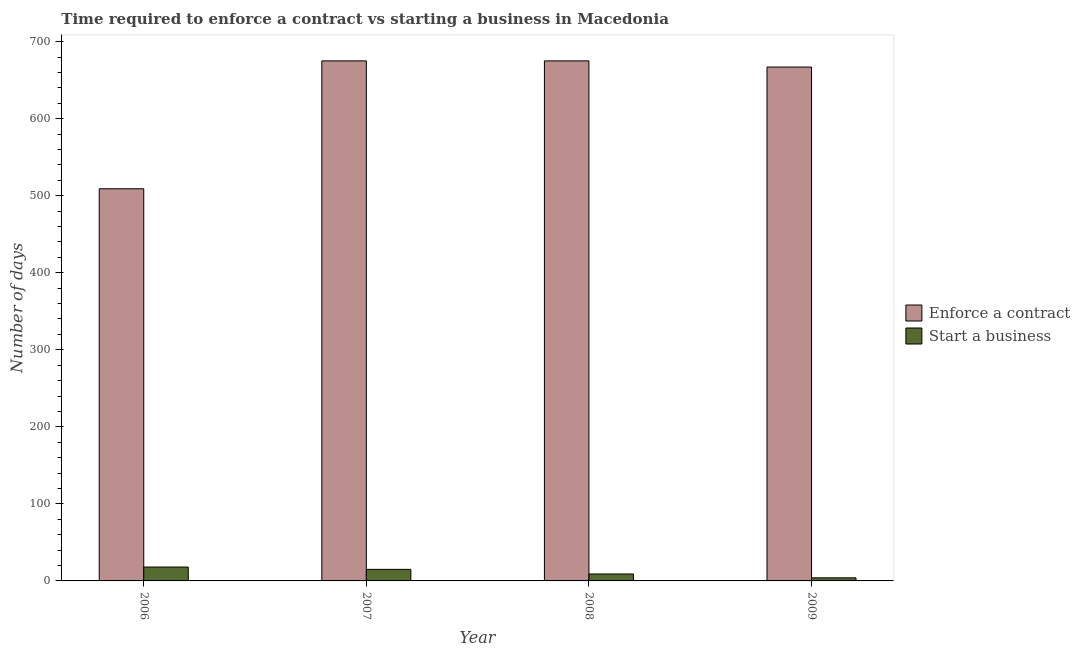How many different coloured bars are there?
Ensure brevity in your answer.  2. Are the number of bars on each tick of the X-axis equal?
Provide a short and direct response. Yes. What is the number of days to start a business in 2007?
Offer a terse response. 15. Across all years, what is the maximum number of days to enforece a contract?
Provide a succinct answer. 675. Across all years, what is the minimum number of days to enforece a contract?
Provide a short and direct response. 509. In which year was the number of days to enforece a contract maximum?
Your answer should be compact. 2007. In which year was the number of days to start a business minimum?
Keep it short and to the point. 2009. What is the total number of days to enforece a contract in the graph?
Give a very brief answer. 2526. What is the difference between the number of days to start a business in 2006 and that in 2008?
Provide a succinct answer. 9. What is the difference between the number of days to enforece a contract in 2009 and the number of days to start a business in 2006?
Ensure brevity in your answer.  158. What is the average number of days to enforece a contract per year?
Your response must be concise. 631.5. In the year 2007, what is the difference between the number of days to enforece a contract and number of days to start a business?
Your answer should be very brief. 0. In how many years, is the number of days to enforece a contract greater than 280 days?
Keep it short and to the point. 4. What is the ratio of the number of days to enforece a contract in 2006 to that in 2008?
Provide a short and direct response. 0.75. Is the difference between the number of days to start a business in 2006 and 2007 greater than the difference between the number of days to enforece a contract in 2006 and 2007?
Your answer should be compact. No. What is the difference between the highest and the lowest number of days to enforece a contract?
Make the answer very short. 166. In how many years, is the number of days to enforece a contract greater than the average number of days to enforece a contract taken over all years?
Provide a short and direct response. 3. What does the 2nd bar from the left in 2007 represents?
Give a very brief answer. Start a business. What does the 1st bar from the right in 2007 represents?
Offer a terse response. Start a business. How many bars are there?
Provide a succinct answer. 8. Are all the bars in the graph horizontal?
Ensure brevity in your answer.  No. Are the values on the major ticks of Y-axis written in scientific E-notation?
Your answer should be very brief. No. Does the graph contain any zero values?
Ensure brevity in your answer.  No. Where does the legend appear in the graph?
Your response must be concise. Center right. How many legend labels are there?
Your response must be concise. 2. How are the legend labels stacked?
Offer a very short reply. Vertical. What is the title of the graph?
Ensure brevity in your answer.  Time required to enforce a contract vs starting a business in Macedonia. What is the label or title of the Y-axis?
Your response must be concise. Number of days. What is the Number of days in Enforce a contract in 2006?
Offer a very short reply. 509. What is the Number of days of Enforce a contract in 2007?
Offer a very short reply. 675. What is the Number of days of Enforce a contract in 2008?
Ensure brevity in your answer.  675. What is the Number of days in Enforce a contract in 2009?
Offer a terse response. 667. Across all years, what is the maximum Number of days in Enforce a contract?
Provide a succinct answer. 675. Across all years, what is the maximum Number of days in Start a business?
Your response must be concise. 18. Across all years, what is the minimum Number of days in Enforce a contract?
Ensure brevity in your answer.  509. Across all years, what is the minimum Number of days of Start a business?
Offer a very short reply. 4. What is the total Number of days in Enforce a contract in the graph?
Your answer should be very brief. 2526. What is the total Number of days of Start a business in the graph?
Your answer should be compact. 46. What is the difference between the Number of days in Enforce a contract in 2006 and that in 2007?
Your response must be concise. -166. What is the difference between the Number of days of Enforce a contract in 2006 and that in 2008?
Your answer should be very brief. -166. What is the difference between the Number of days of Enforce a contract in 2006 and that in 2009?
Keep it short and to the point. -158. What is the difference between the Number of days in Enforce a contract in 2007 and that in 2009?
Provide a short and direct response. 8. What is the difference between the Number of days in Start a business in 2007 and that in 2009?
Offer a very short reply. 11. What is the difference between the Number of days in Enforce a contract in 2008 and that in 2009?
Your response must be concise. 8. What is the difference between the Number of days of Start a business in 2008 and that in 2009?
Offer a very short reply. 5. What is the difference between the Number of days of Enforce a contract in 2006 and the Number of days of Start a business in 2007?
Your answer should be compact. 494. What is the difference between the Number of days of Enforce a contract in 2006 and the Number of days of Start a business in 2009?
Your response must be concise. 505. What is the difference between the Number of days of Enforce a contract in 2007 and the Number of days of Start a business in 2008?
Your answer should be compact. 666. What is the difference between the Number of days of Enforce a contract in 2007 and the Number of days of Start a business in 2009?
Provide a short and direct response. 671. What is the difference between the Number of days in Enforce a contract in 2008 and the Number of days in Start a business in 2009?
Provide a short and direct response. 671. What is the average Number of days in Enforce a contract per year?
Provide a succinct answer. 631.5. In the year 2006, what is the difference between the Number of days in Enforce a contract and Number of days in Start a business?
Ensure brevity in your answer.  491. In the year 2007, what is the difference between the Number of days in Enforce a contract and Number of days in Start a business?
Keep it short and to the point. 660. In the year 2008, what is the difference between the Number of days of Enforce a contract and Number of days of Start a business?
Your response must be concise. 666. In the year 2009, what is the difference between the Number of days of Enforce a contract and Number of days of Start a business?
Give a very brief answer. 663. What is the ratio of the Number of days of Enforce a contract in 2006 to that in 2007?
Ensure brevity in your answer.  0.75. What is the ratio of the Number of days in Enforce a contract in 2006 to that in 2008?
Your answer should be very brief. 0.75. What is the ratio of the Number of days in Start a business in 2006 to that in 2008?
Your response must be concise. 2. What is the ratio of the Number of days of Enforce a contract in 2006 to that in 2009?
Ensure brevity in your answer.  0.76. What is the ratio of the Number of days in Start a business in 2006 to that in 2009?
Ensure brevity in your answer.  4.5. What is the ratio of the Number of days of Start a business in 2007 to that in 2008?
Offer a very short reply. 1.67. What is the ratio of the Number of days of Start a business in 2007 to that in 2009?
Make the answer very short. 3.75. What is the ratio of the Number of days of Start a business in 2008 to that in 2009?
Your answer should be compact. 2.25. What is the difference between the highest and the second highest Number of days of Enforce a contract?
Offer a very short reply. 0. What is the difference between the highest and the lowest Number of days of Enforce a contract?
Keep it short and to the point. 166. What is the difference between the highest and the lowest Number of days of Start a business?
Your response must be concise. 14. 